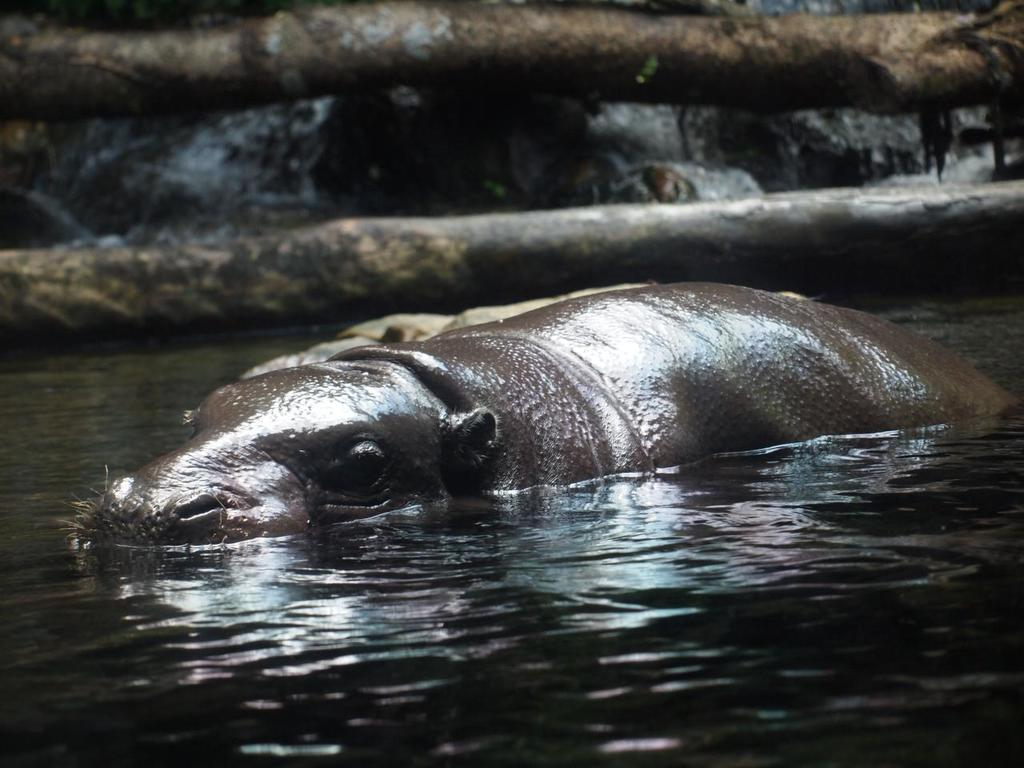What is the animal doing in the image? The animal is in the water. What else can be seen in the image besides the animal? There are trunks visible in the image. What type of collar is being worn by the team in the image? There is no team or collar present in the image; it features an animal in the water and trunks. 